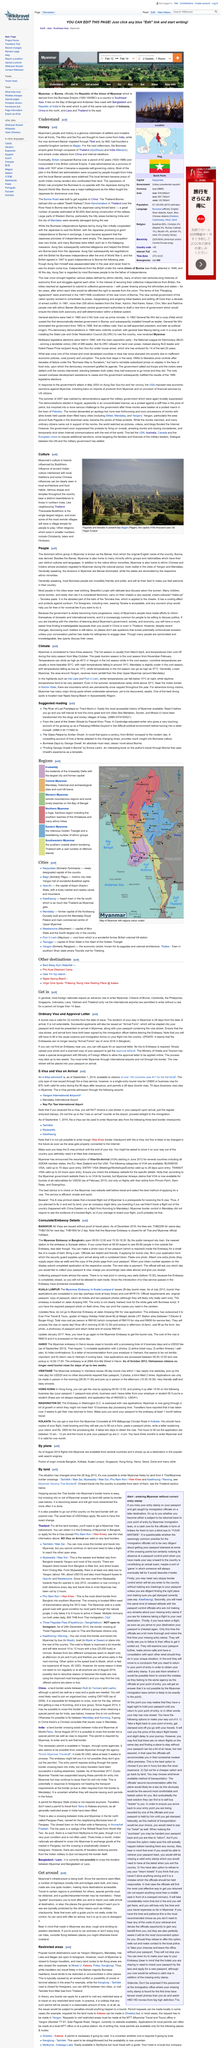Identify some key points in this picture. Myanmar is located on the Bay of Bengal. The check-in/check-out for the country officially known as the Republic of the Union of Myanmar is scheduled for February 12 to February 14, according to the official designation of the country. The image depicts pagodas and temples in present-day Bagan, Myanmar. Myanmar, a country located in Southeast Asia, is known for its rich cultural heritage and stunning natural beauty. There exist various religions, with Christianity, Islam, and Hinduism being some of the lesser practiced ones. 